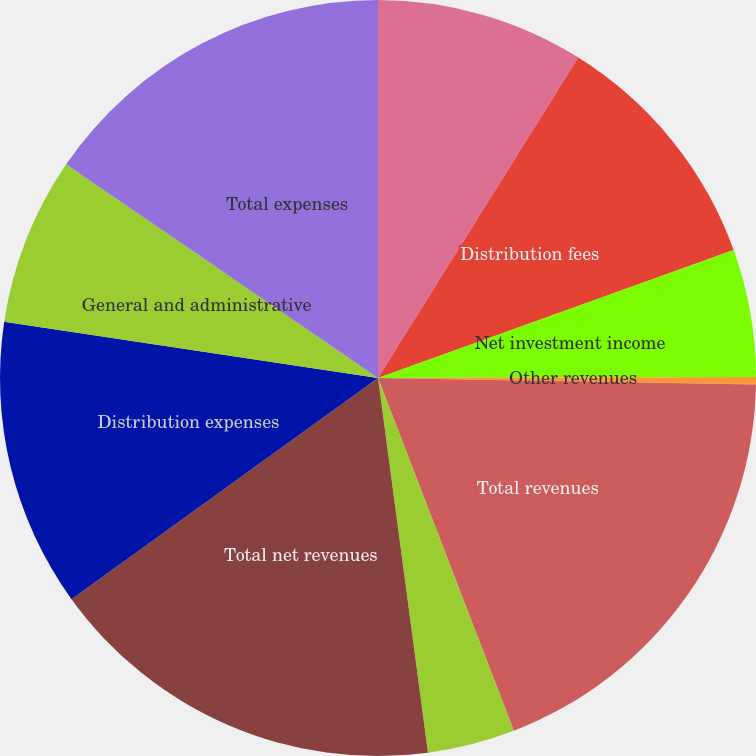Convert chart. <chart><loc_0><loc_0><loc_500><loc_500><pie_chart><fcel>Management and financial<fcel>Distribution fees<fcel>Net investment income<fcel>Other revenues<fcel>Total revenues<fcel>Banking and deposit interest<fcel>Total net revenues<fcel>Distribution expenses<fcel>General and administrative<fcel>Total expenses<nl><fcel>8.89%<fcel>10.61%<fcel>5.46%<fcel>0.31%<fcel>18.88%<fcel>3.74%<fcel>17.16%<fcel>12.33%<fcel>7.18%<fcel>15.44%<nl></chart> 